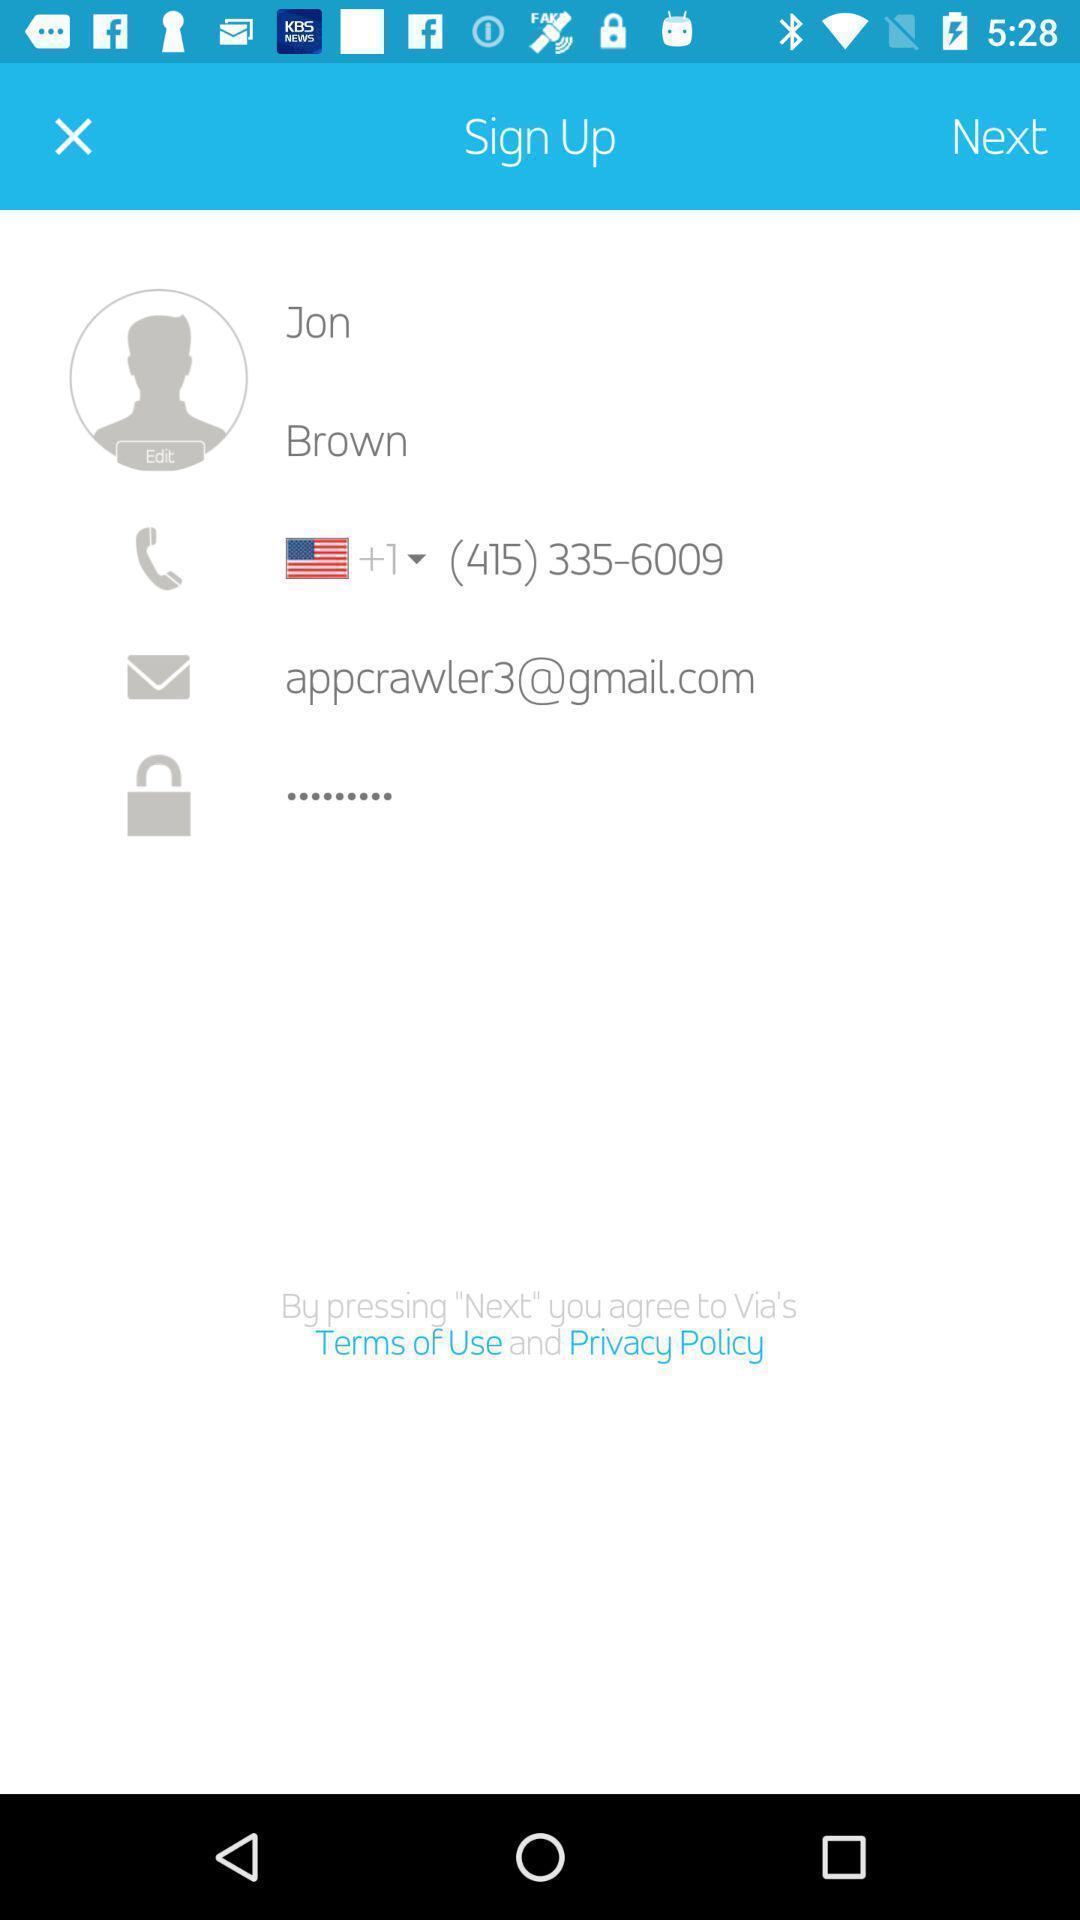What details can you identify in this image? Sign-up page for a ride-hailing app. 